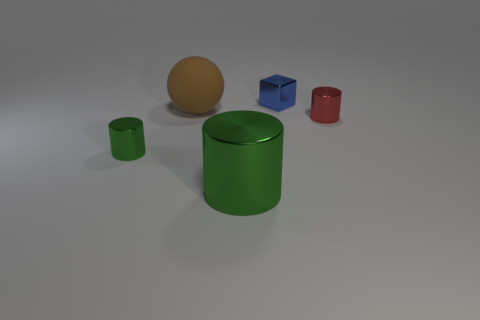Is there a green cylinder made of the same material as the blue thing? Yes, the green cylinder shares a shiny appearance with the smaller blue cube, indicating that they are made from a similar material with a glossy finish. 